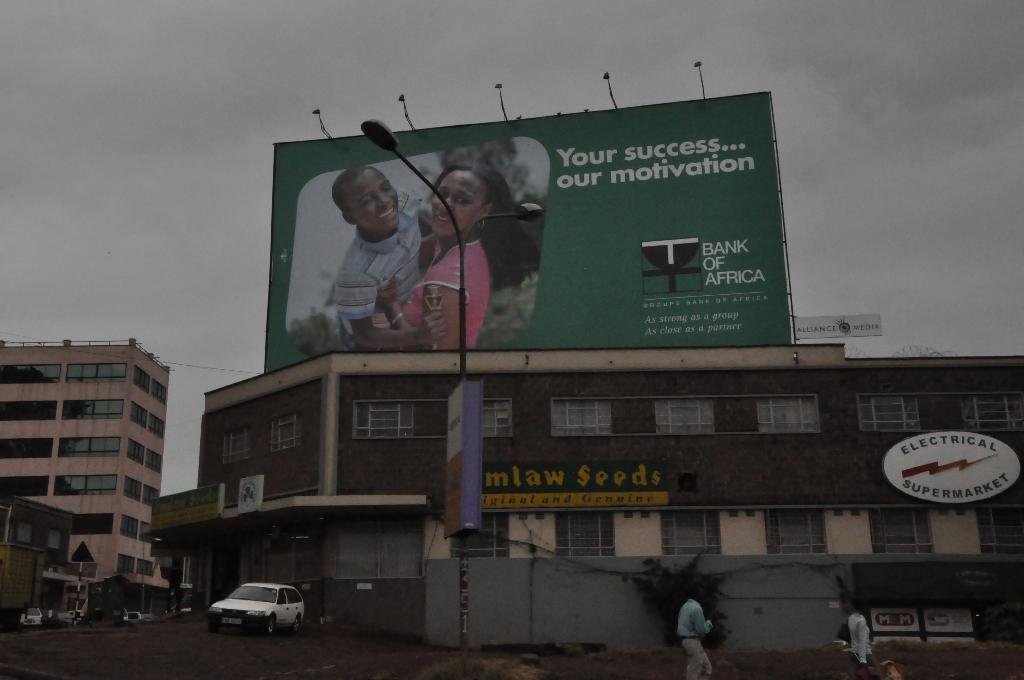<image>
Relay a brief, clear account of the picture shown. A huge bank of africa sign stands upon a seeds shop and electrical shop. 